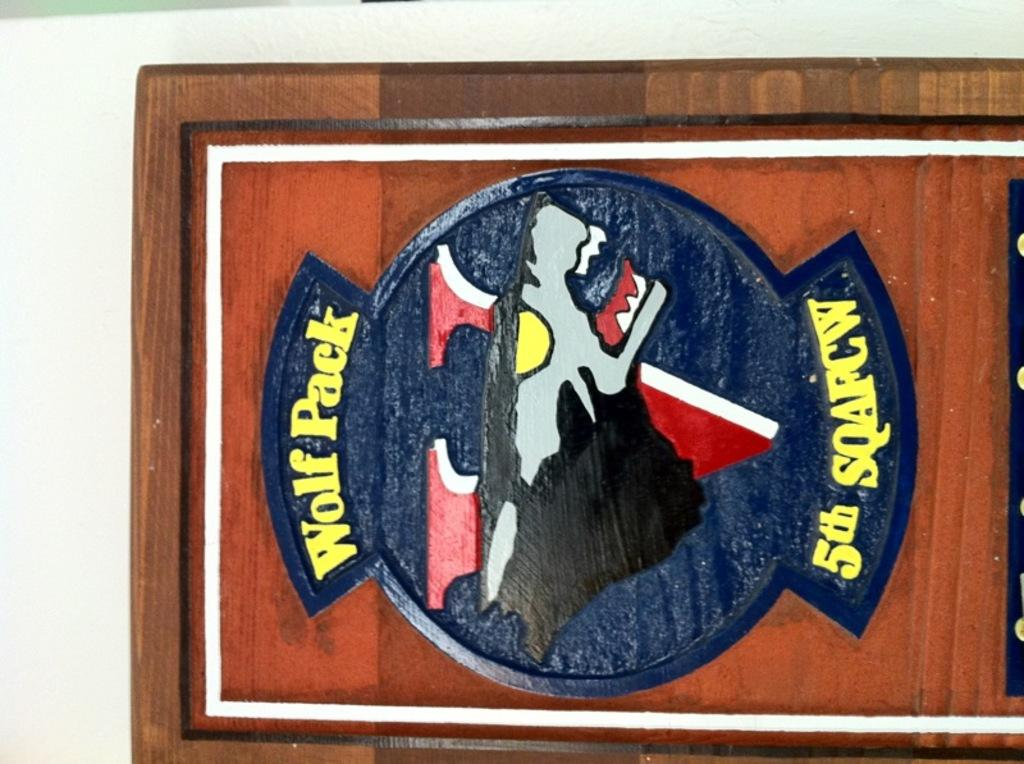<image>
Share a concise interpretation of the image provided. A logo for the Wolf Pack 5th SQAFCW features a wolf's head on a V. 